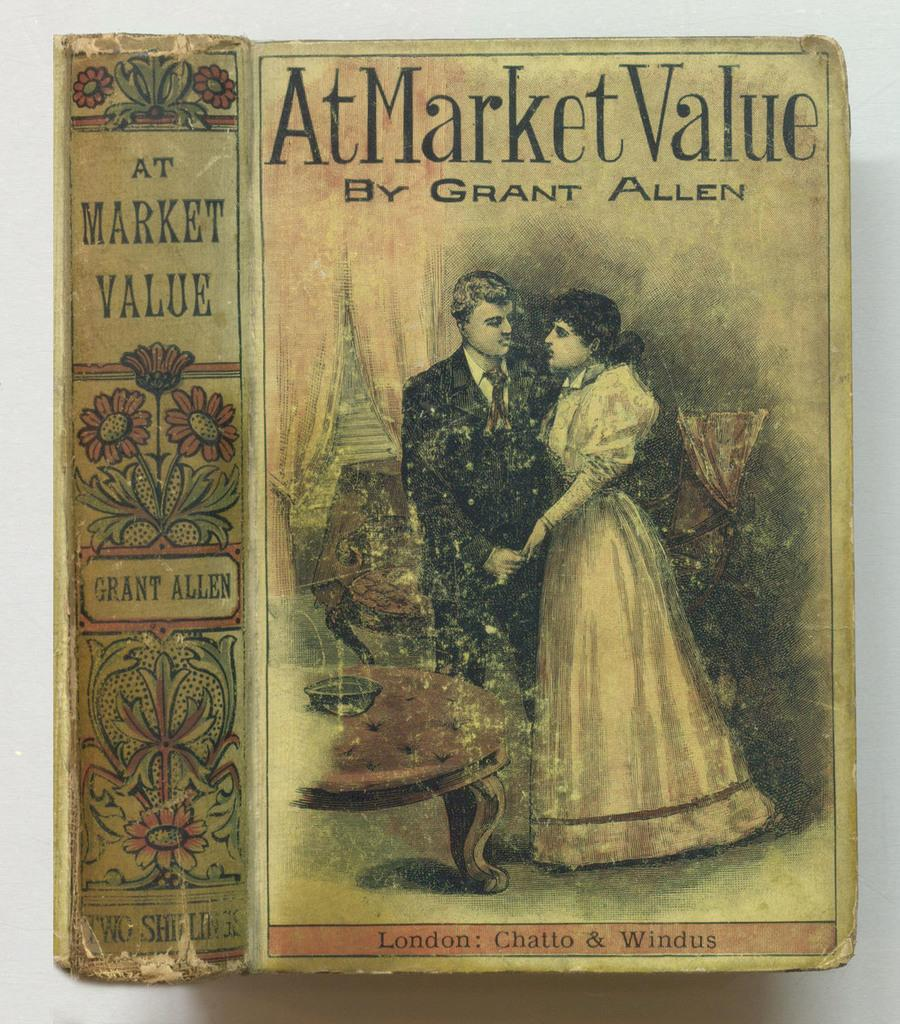Provide a one-sentence caption for the provided image. A book by Grant Allen shows a couple on the front. 